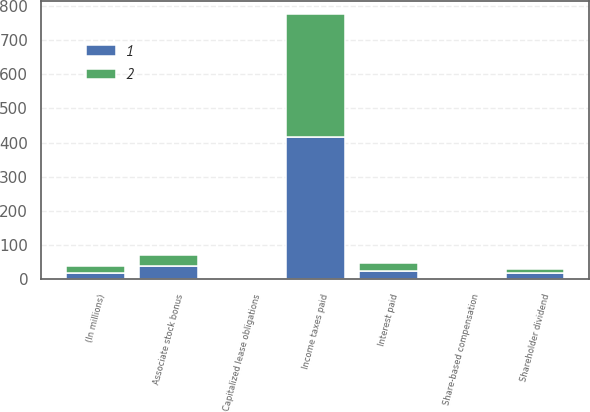Convert chart to OTSL. <chart><loc_0><loc_0><loc_500><loc_500><stacked_bar_chart><ecel><fcel>(In millions)<fcel>Income taxes paid<fcel>Interest paid<fcel>Capitalized lease obligations<fcel>Associate stock bonus<fcel>Shareholder dividend<fcel>Share-based compensation<nl><fcel>1<fcel>20<fcel>416<fcel>26<fcel>1<fcel>38<fcel>19<fcel>2<nl><fcel>2<fcel>20<fcel>360<fcel>21<fcel>4<fcel>33<fcel>11<fcel>1<nl></chart> 